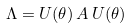Convert formula to latex. <formula><loc_0><loc_0><loc_500><loc_500>\Lambda = U ( \theta ) \, A \, U ( \theta )</formula> 